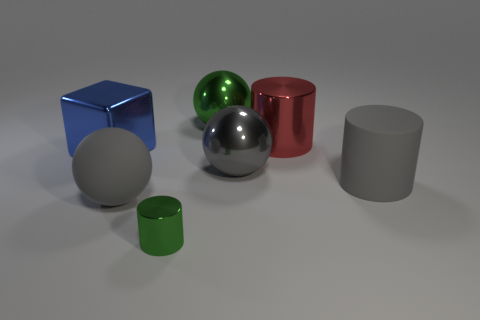Are there any other things that have the same size as the green cylinder?
Offer a very short reply. No. What color is the matte sphere that is the same size as the red shiny thing?
Provide a short and direct response. Gray. How big is the green shiny cylinder?
Ensure brevity in your answer.  Small. Are the big object behind the big shiny cylinder and the large red cylinder made of the same material?
Offer a terse response. Yes. Is the large green object the same shape as the large gray metallic object?
Your answer should be compact. Yes. There is a large green shiny thing behind the big metal object that is left of the ball that is in front of the gray metallic ball; what is its shape?
Keep it short and to the point. Sphere. There is a big gray rubber object that is behind the big rubber ball; is it the same shape as the green object to the right of the tiny object?
Keep it short and to the point. No. Is there a big object that has the same material as the big gray cylinder?
Your answer should be compact. Yes. The shiny cylinder that is behind the large gray matte thing that is on the right side of the green metal thing that is in front of the large blue metal object is what color?
Keep it short and to the point. Red. Are the sphere behind the big red cylinder and the big cylinder behind the big gray cylinder made of the same material?
Offer a terse response. Yes. 